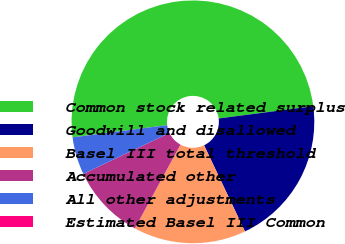<chart> <loc_0><loc_0><loc_500><loc_500><pie_chart><fcel>Common stock related surplus<fcel>Goodwill and disallowed<fcel>Basel III total threshold<fcel>Accumulated other<fcel>All other adjustments<fcel>Estimated Basel III Common<nl><fcel>49.98%<fcel>20.0%<fcel>15.0%<fcel>10.0%<fcel>5.01%<fcel>0.01%<nl></chart> 